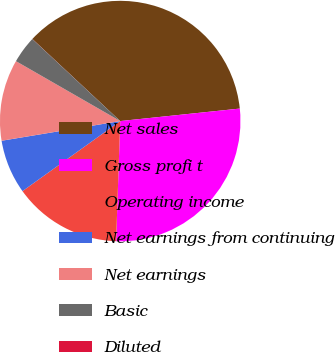<chart> <loc_0><loc_0><loc_500><loc_500><pie_chart><fcel>Net sales<fcel>Gross profi t<fcel>Operating income<fcel>Net earnings from continuing<fcel>Net earnings<fcel>Basic<fcel>Diluted<nl><fcel>36.38%<fcel>27.2%<fcel>14.56%<fcel>7.28%<fcel>10.92%<fcel>3.65%<fcel>0.01%<nl></chart> 